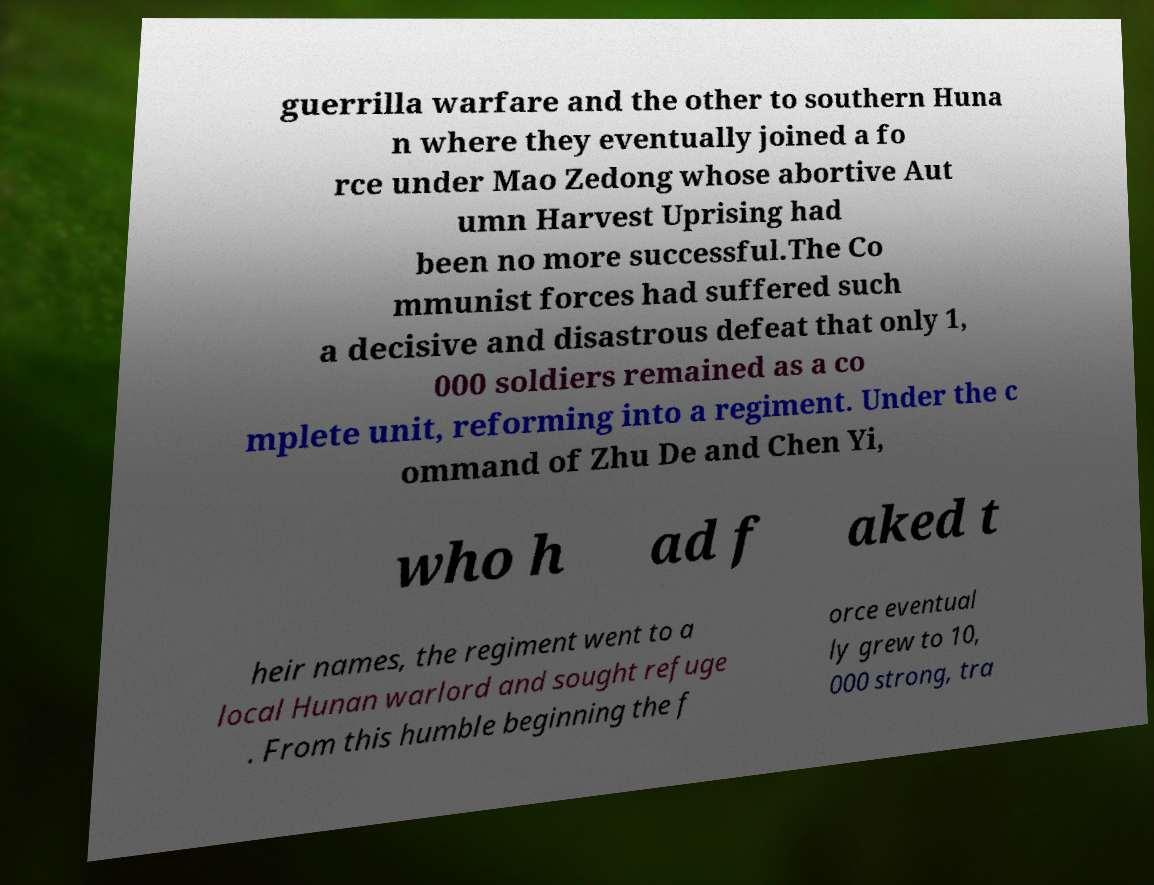Can you accurately transcribe the text from the provided image for me? guerrilla warfare and the other to southern Huna n where they eventually joined a fo rce under Mao Zedong whose abortive Aut umn Harvest Uprising had been no more successful.The Co mmunist forces had suffered such a decisive and disastrous defeat that only 1, 000 soldiers remained as a co mplete unit, reforming into a regiment. Under the c ommand of Zhu De and Chen Yi, who h ad f aked t heir names, the regiment went to a local Hunan warlord and sought refuge . From this humble beginning the f orce eventual ly grew to 10, 000 strong, tra 